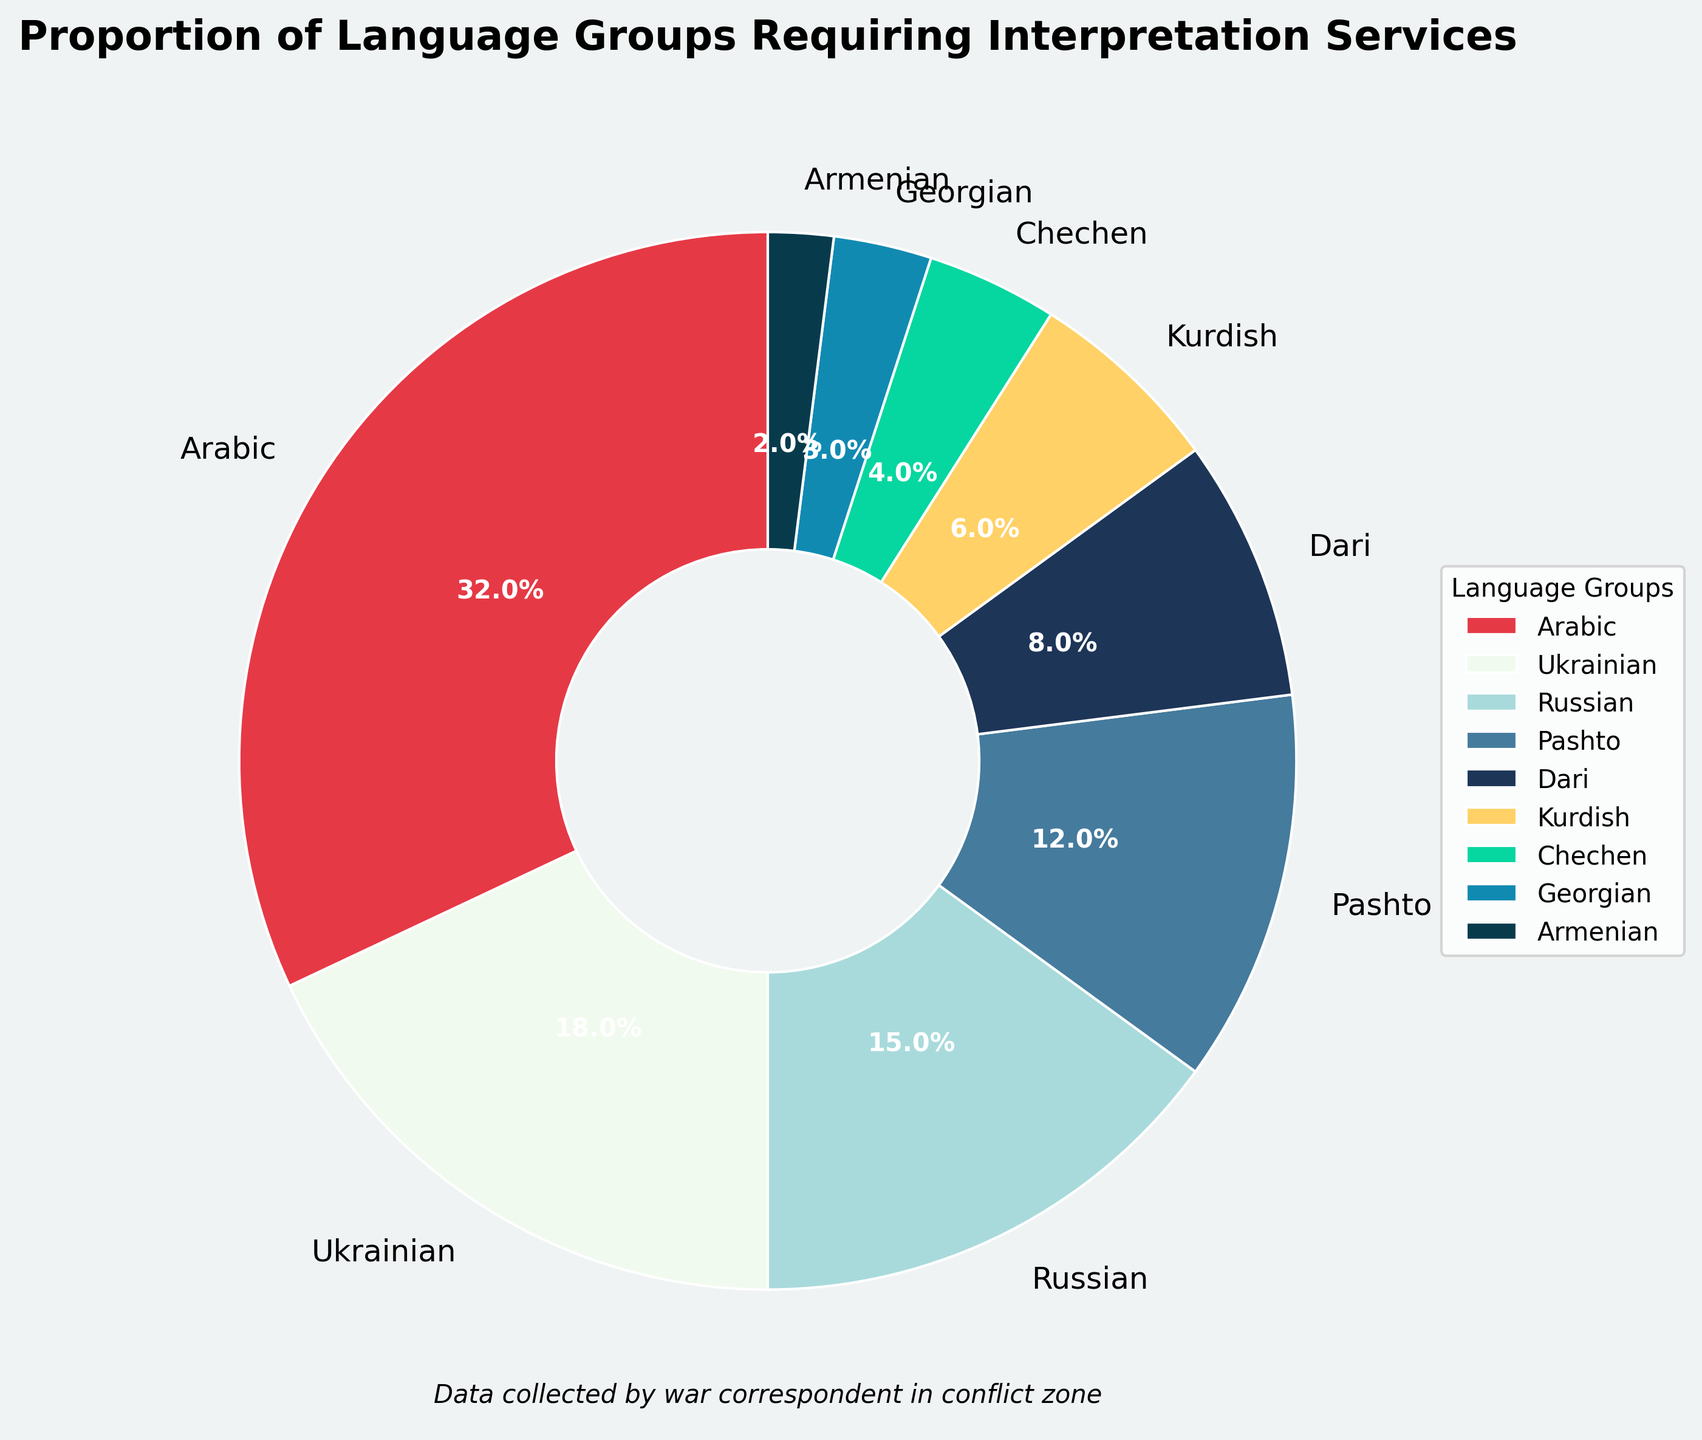What language group requires interpretation services the most? The chart shows various language groups with their respective percentages. The largest section of the pie chart corresponds to Arabic, which covers 32%.
Answer: Arabic Which language group requires the least interpretation services? The smallest section of the pie chart is labelled as Armenian, with a percentage of 2%.
Answer: Armenian What combined percentage of services is required by the two smallest language groups? Identifying the two smallest sections on the pie chart, which are Armenian (2%) and Georgian (3%). Adding these values: 2% + 3% = 5%.
Answer: 5% How does the proportion of Arabic compare to Ukrainian and Russian combined? The pie chart shows Arabic at 32%, Ukrainian at 18%, and Russian at 15%. Summing Ukrainian and Russian yields 18% + 15% = 33%. Arabic's 32% is slightly less than Ukrainian and Russian combined.
Answer: Ukrainian and Russian combined is slightly more If you combine the percentages of Pashto and Dari, what is their combined share relative to the entire chart? The pie chart states that Pashto is 12% and Dari is 8%. Adding these values gives 12% + 8% = 20%. They represent one-fifth of the total chart (20% of 100%).
Answer: 20% Which language group occupies a darker blue segment in the pie chart? The chart uses varying shades of blue. Identifying 'Darker Blue' segment, the language group corresponding to this color is Georgian.
Answer: Georgian Is the percentage of Kurdish interpretation services closer to Arabic or Ukrainian? The pie chart indicates Kurdish at 6%, Arabic at 32%, and Ukrainian at 18%. Comparing the differences: 32% - 6% = 26%, 18% - 6% = 12%. Kurdish is closer to Ukrainian.
Answer: Ukrainian What is the difference in percentage points between the highest and lowest required interpretation services? The chart shows the highest percentage is Arabic at 32% and the lowest is Armenian at 2%. The difference is 32% - 2% = 30%.
Answer: 30% Between which two consecutive language groups is the percentage difference most significant? Reviewing the chart, the two most disparate figures are from Arabic (32%) to Ukrainian (18%), with a difference of 32% - 18% = 14%.
Answer: Arabic and Ukrainian If you wanted to represent half of the chart with just two language groups, which ones would you choose? Adding the highest percentages, Arabic at 32% and Ukrainian at 18%, gives 32% + 18% = 50%, covering half of the chart.
Answer: Arabic and Ukrainian 